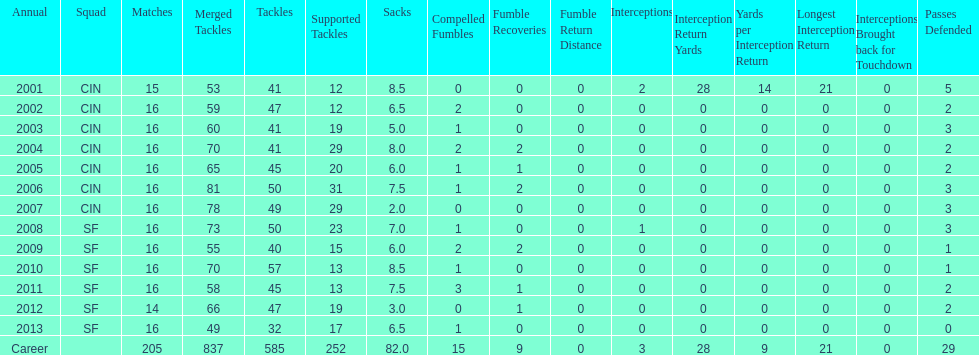What is the only season he has fewer than three sacks? 2007. 